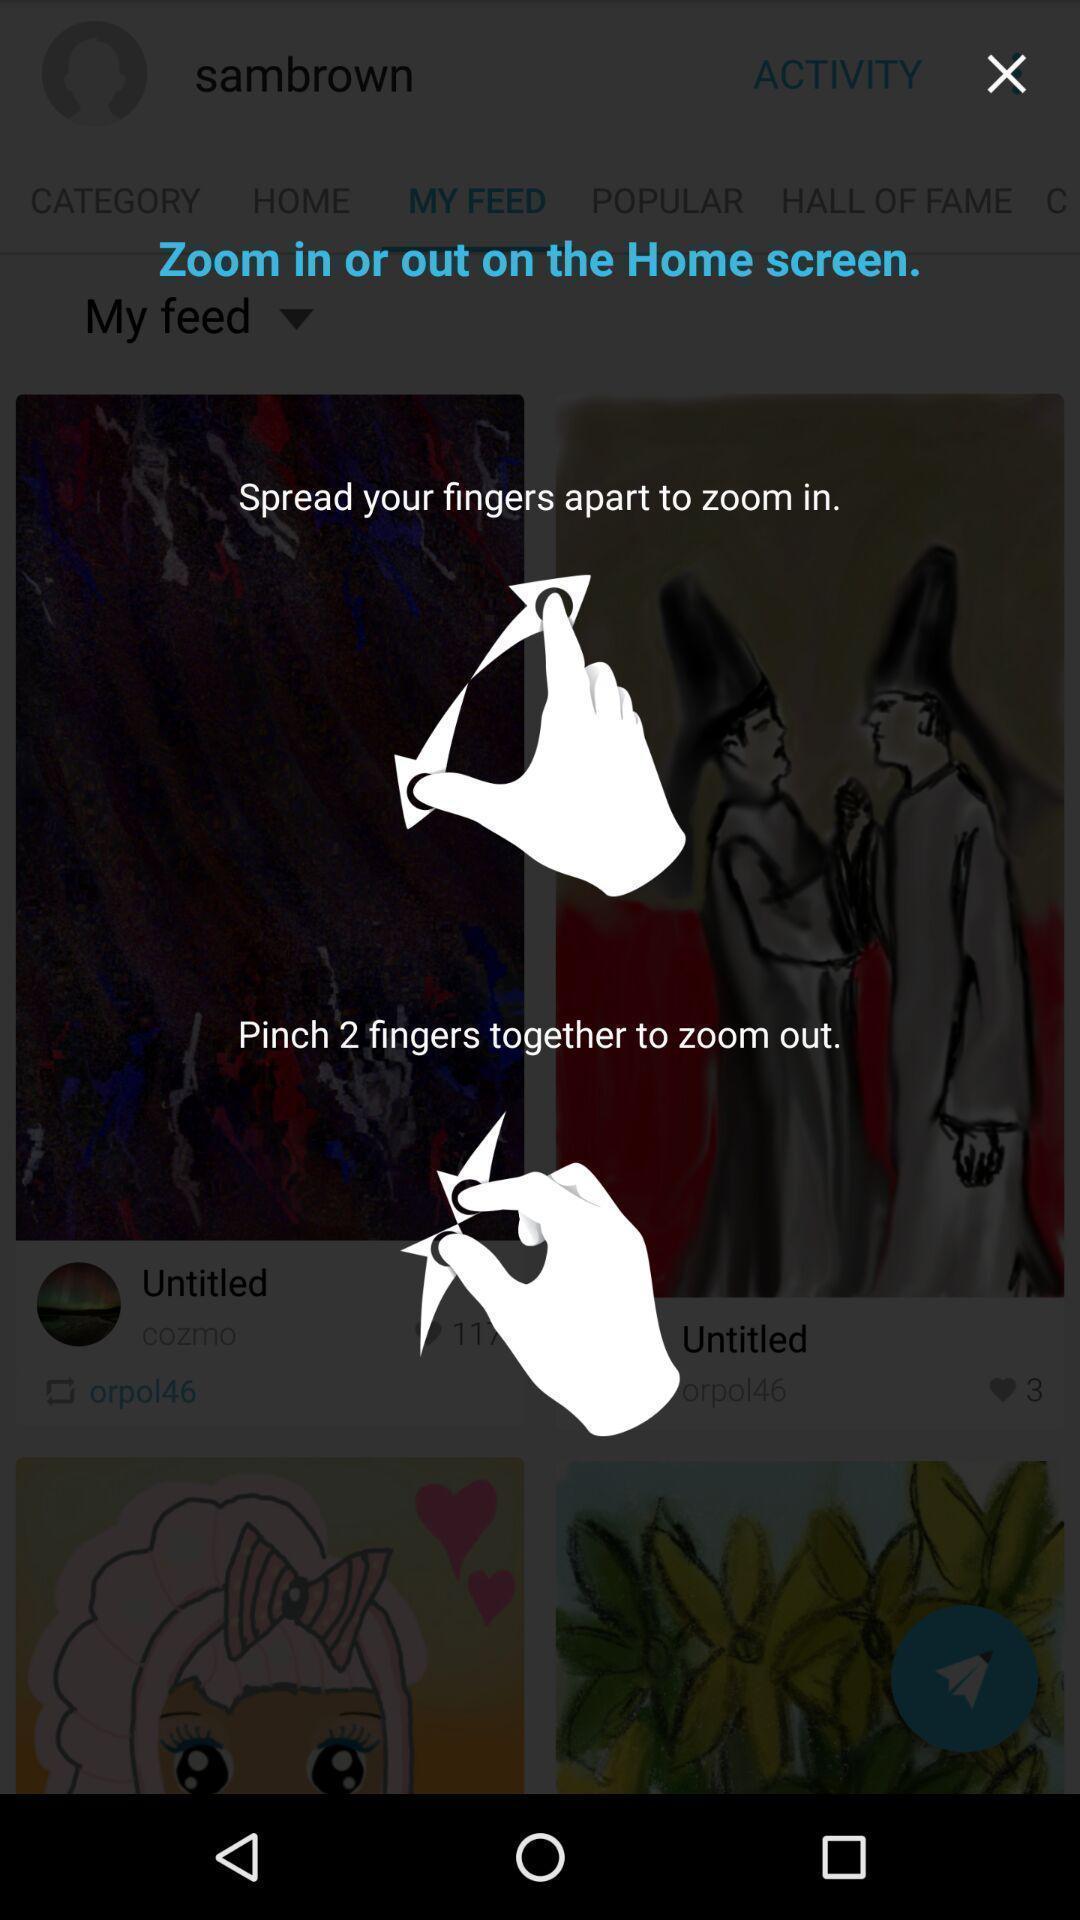Tell me about the visual elements in this screen capture. Zoom gesture introduction page in an imaging app. 